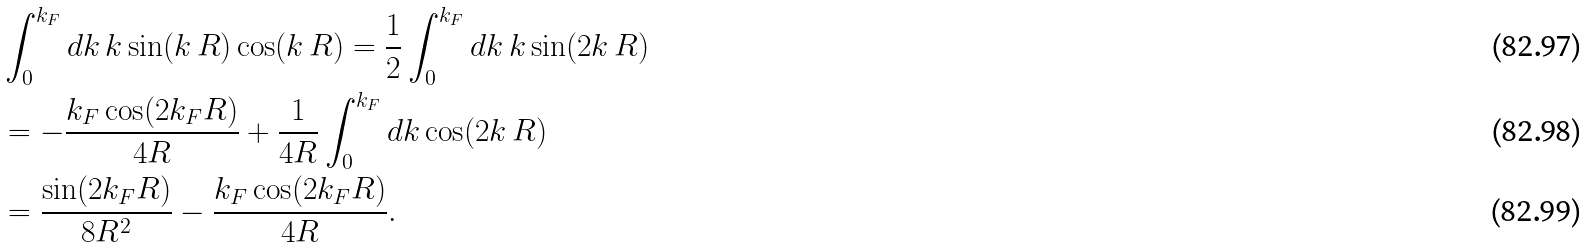<formula> <loc_0><loc_0><loc_500><loc_500>& \int _ { 0 } ^ { k _ { F } } d k \, k \sin ( k \, R ) \cos ( k \, R ) = \frac { 1 } { 2 } \int _ { 0 } ^ { k _ { F } } d k \, k \sin ( 2 k \, R ) \\ & = - \frac { k _ { F } \cos ( 2 k _ { F } R ) } { 4 R } + \frac { 1 } { 4 R } \int _ { 0 } ^ { k _ { F } } d k \cos ( 2 k \, R ) \\ & = \frac { \sin ( 2 k _ { F } R ) } { 8 R ^ { 2 } } - \frac { k _ { F } \cos ( 2 k _ { F } R ) } { 4 R } .</formula> 